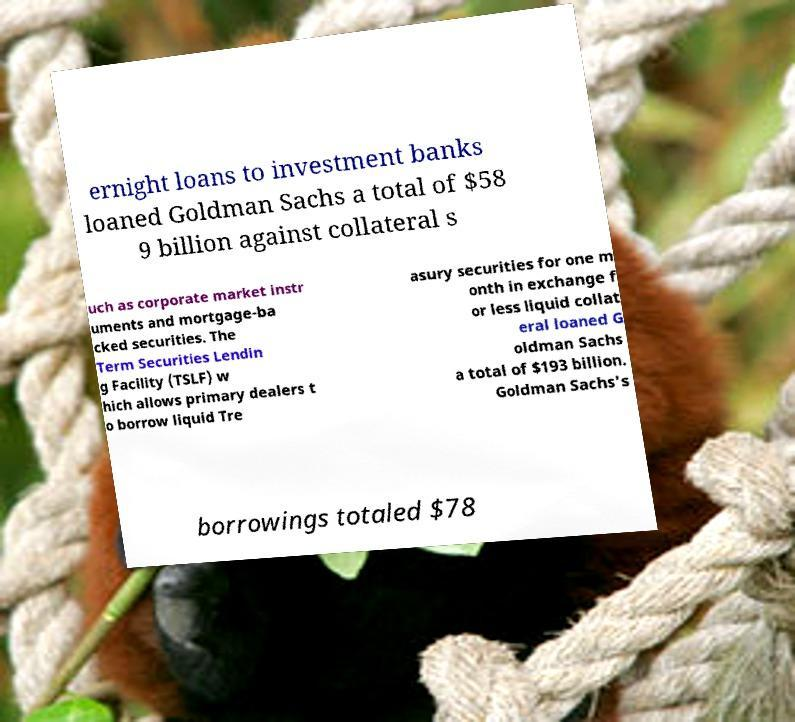Could you assist in decoding the text presented in this image and type it out clearly? ernight loans to investment banks loaned Goldman Sachs a total of $58 9 billion against collateral s uch as corporate market instr uments and mortgage-ba cked securities. The Term Securities Lendin g Facility (TSLF) w hich allows primary dealers t o borrow liquid Tre asury securities for one m onth in exchange f or less liquid collat eral loaned G oldman Sachs a total of $193 billion. Goldman Sachs's borrowings totaled $78 